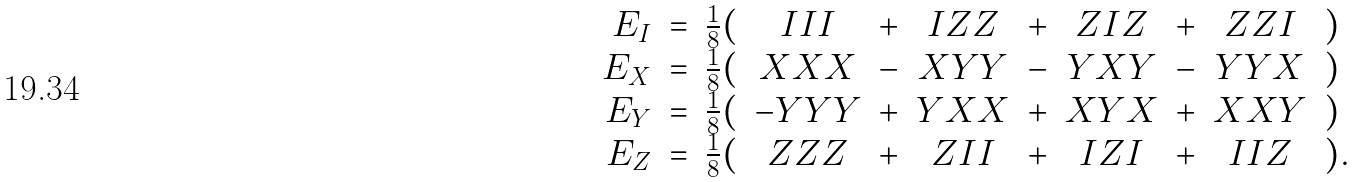Convert formula to latex. <formula><loc_0><loc_0><loc_500><loc_500>\begin{array} { r c l c c c c c c c l } E _ { I } & = & \frac { 1 } { 8 } ( & I I I & + & I Z Z & + & Z I Z & + & Z Z I & ) \\ E _ { X } & = & \frac { 1 } { 8 } ( & X X X & - & X Y Y & - & Y X Y & - & Y Y X & ) \\ E _ { Y } & = & \frac { 1 } { 8 } ( & - Y Y Y & + & Y X X & + & X Y X & + & X X Y & ) \\ E _ { Z } & = & \frac { 1 } { 8 } ( & Z Z Z & + & Z I I & + & I Z I & + & I I Z & ) . \end{array}</formula> 